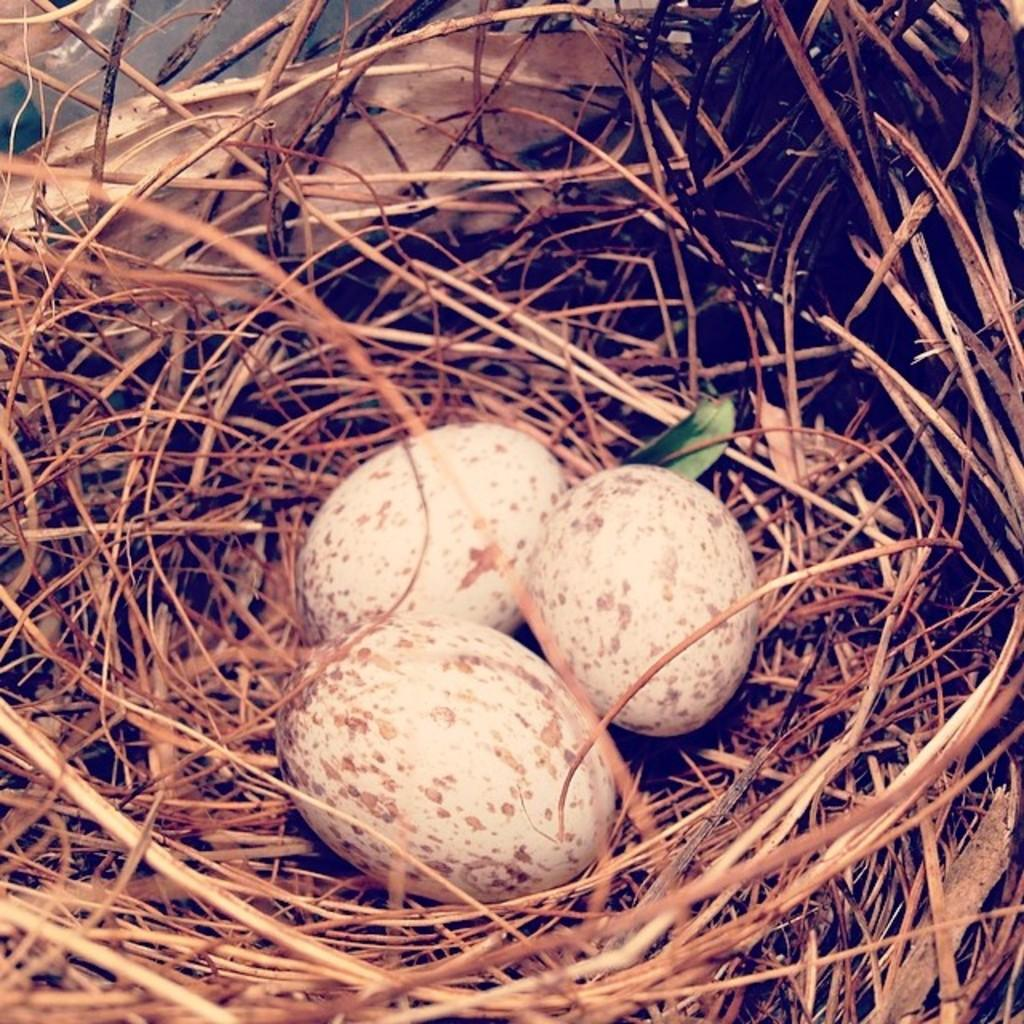How many eggs are visible in the image? There are three eggs in the image. Where are the eggs located? The eggs are in a nest. What type of fold can be seen in the image? There is no fold present in the image; it features three eggs in a nest. What type of breakfast is being prepared in the image? There is no indication of breakfast being prepared in the image; it only shows three eggs in a nest. 